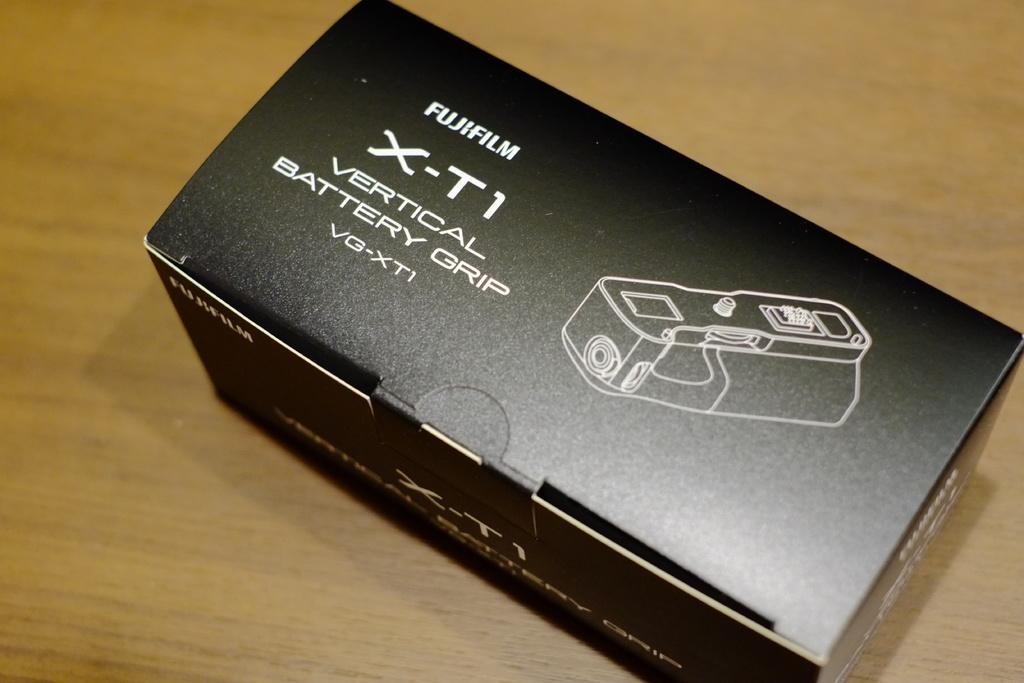Provide a one-sentence caption for the provided image. a box that has a fujifulm x-t1 battery grip. 